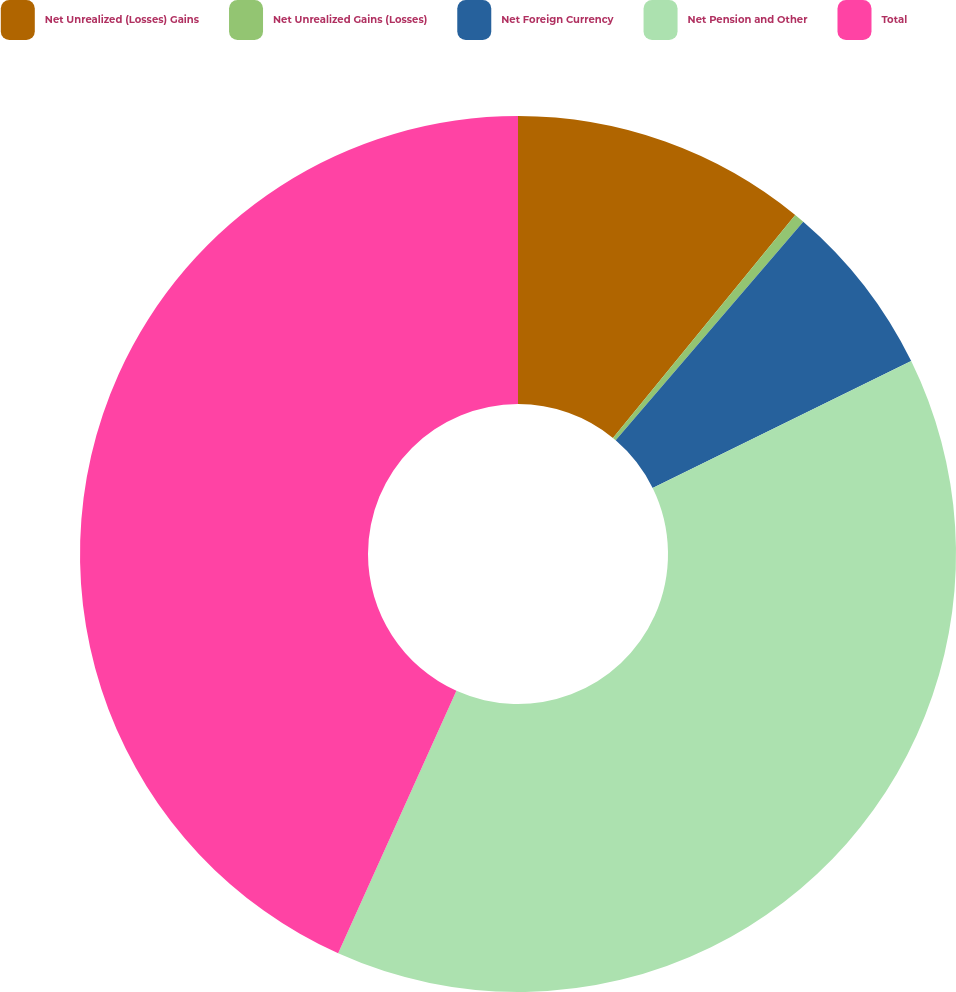Convert chart. <chart><loc_0><loc_0><loc_500><loc_500><pie_chart><fcel>Net Unrealized (Losses) Gains<fcel>Net Unrealized Gains (Losses)<fcel>Net Foreign Currency<fcel>Net Pension and Other<fcel>Total<nl><fcel>10.91%<fcel>0.38%<fcel>6.45%<fcel>39.0%<fcel>43.27%<nl></chart> 